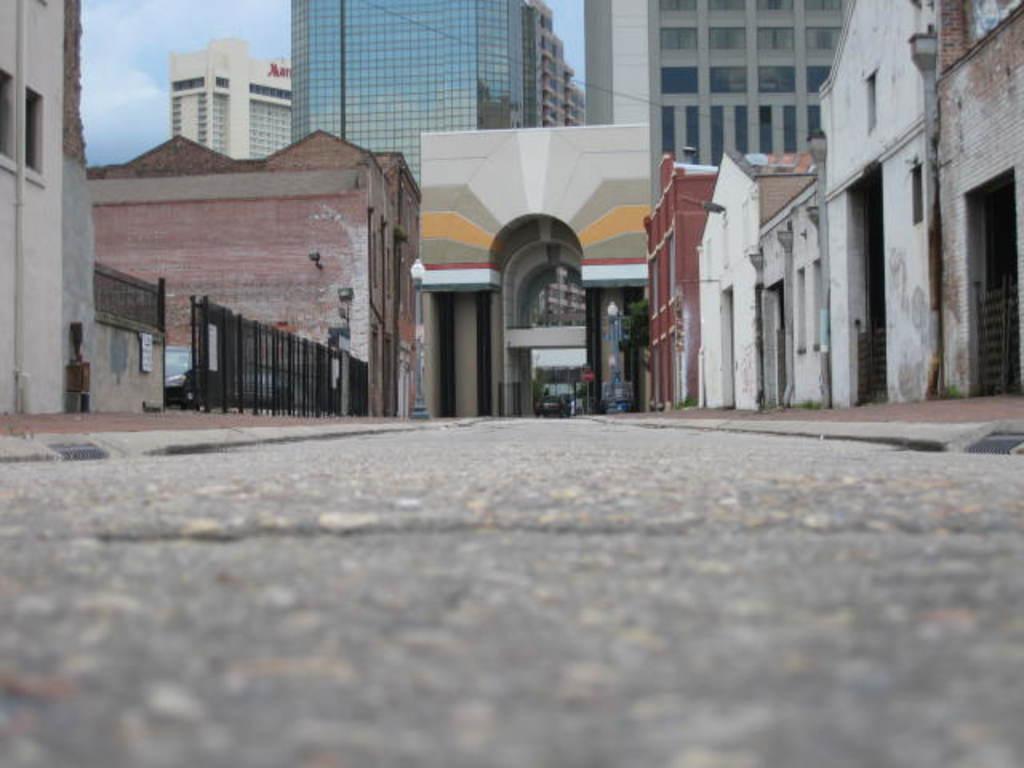Describe this image in one or two sentences. This is a road and there is a car. Here we can see houses, fence, poles, lights, and buildings. In the background there is sky. 